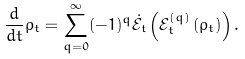Convert formula to latex. <formula><loc_0><loc_0><loc_500><loc_500>\frac { d } { d t } \rho _ { t } = \sum _ { q = 0 } ^ { \infty } ( - 1 ) ^ { q } \dot { \mathfrak { \mathcal { E } _ { t } } } \left ( \mathfrak { \mathcal { E } } _ { t } ^ { ( q ) } \left ( \rho _ { t } \right ) \right ) .</formula> 